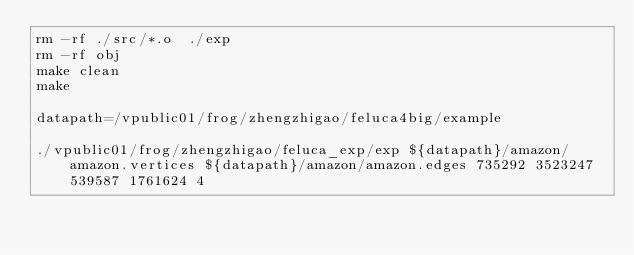<code> <loc_0><loc_0><loc_500><loc_500><_Bash_>rm -rf ./src/*.o  ./exp  
rm -rf obj
make clean
make

datapath=/vpublic01/frog/zhengzhigao/feluca4big/example

./vpublic01/frog/zhengzhigao/feluca_exp/exp ${datapath}/amazon/amazon.vertices ${datapath}/amazon/amazon.edges 735292 3523247 539587 1761624 4</code> 